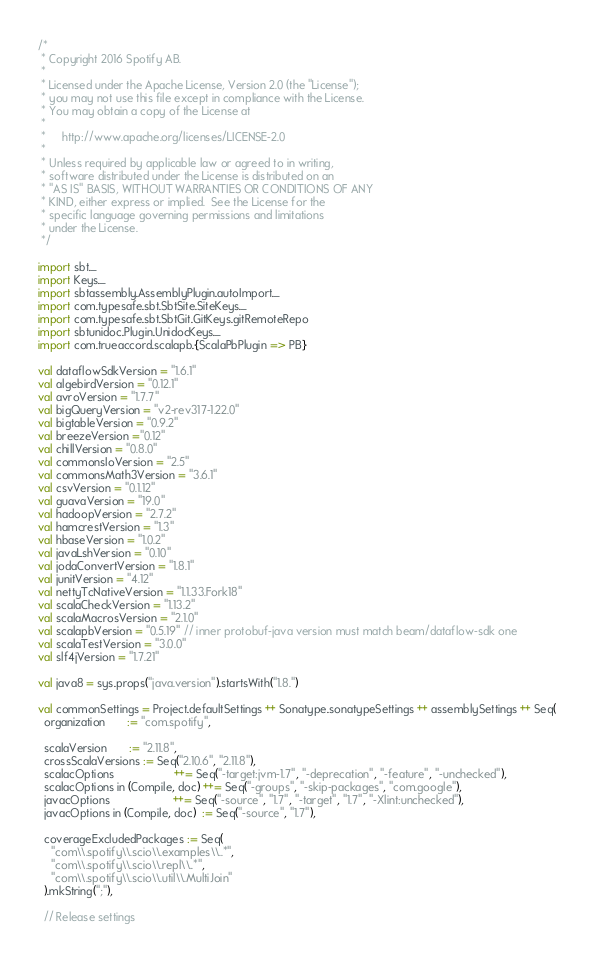Convert code to text. <code><loc_0><loc_0><loc_500><loc_500><_Scala_>/*
 * Copyright 2016 Spotify AB.
 *
 * Licensed under the Apache License, Version 2.0 (the "License");
 * you may not use this file except in compliance with the License.
 * You may obtain a copy of the License at
 *
 *     http://www.apache.org/licenses/LICENSE-2.0
 *
 * Unless required by applicable law or agreed to in writing,
 * software distributed under the License is distributed on an
 * "AS IS" BASIS, WITHOUT WARRANTIES OR CONDITIONS OF ANY
 * KIND, either express or implied.  See the License for the
 * specific language governing permissions and limitations
 * under the License.
 */

import sbt._
import Keys._
import sbtassembly.AssemblyPlugin.autoImport._
import com.typesafe.sbt.SbtSite.SiteKeys._
import com.typesafe.sbt.SbtGit.GitKeys.gitRemoteRepo
import sbtunidoc.Plugin.UnidocKeys._
import com.trueaccord.scalapb.{ScalaPbPlugin => PB}

val dataflowSdkVersion = "1.6.1"
val algebirdVersion = "0.12.1"
val avroVersion = "1.7.7"
val bigQueryVersion = "v2-rev317-1.22.0"
val bigtableVersion = "0.9.2"
val breezeVersion ="0.12"
val chillVersion = "0.8.0"
val commonsIoVersion = "2.5"
val commonsMath3Version = "3.6.1"
val csvVersion = "0.1.12"
val guavaVersion = "19.0"
val hadoopVersion = "2.7.2"
val hamcrestVersion = "1.3"
val hbaseVersion = "1.0.2"
val javaLshVersion = "0.10"
val jodaConvertVersion = "1.8.1"
val junitVersion = "4.12"
val nettyTcNativeVersion = "1.1.33.Fork18"
val scalaCheckVersion = "1.13.2"
val scalaMacrosVersion = "2.1.0"
val scalapbVersion = "0.5.19" // inner protobuf-java version must match beam/dataflow-sdk one
val scalaTestVersion = "3.0.0"
val slf4jVersion = "1.7.21"

val java8 = sys.props("java.version").startsWith("1.8.")

val commonSettings = Project.defaultSettings ++ Sonatype.sonatypeSettings ++ assemblySettings ++ Seq(
  organization       := "com.spotify",

  scalaVersion       := "2.11.8",
  crossScalaVersions := Seq("2.10.6", "2.11.8"),
  scalacOptions                   ++= Seq("-target:jvm-1.7", "-deprecation", "-feature", "-unchecked"),
  scalacOptions in (Compile, doc) ++= Seq("-groups", "-skip-packages", "com.google"),
  javacOptions                    ++= Seq("-source", "1.7", "-target", "1.7", "-Xlint:unchecked"),
  javacOptions in (Compile, doc)  := Seq("-source", "1.7"),

  coverageExcludedPackages := Seq(
    "com\\.spotify\\.scio\\.examples\\..*",
    "com\\.spotify\\.scio\\.repl\\..*",
    "com\\.spotify\\.scio\\.util\\.MultiJoin"
  ).mkString(";"),

  // Release settings</code> 